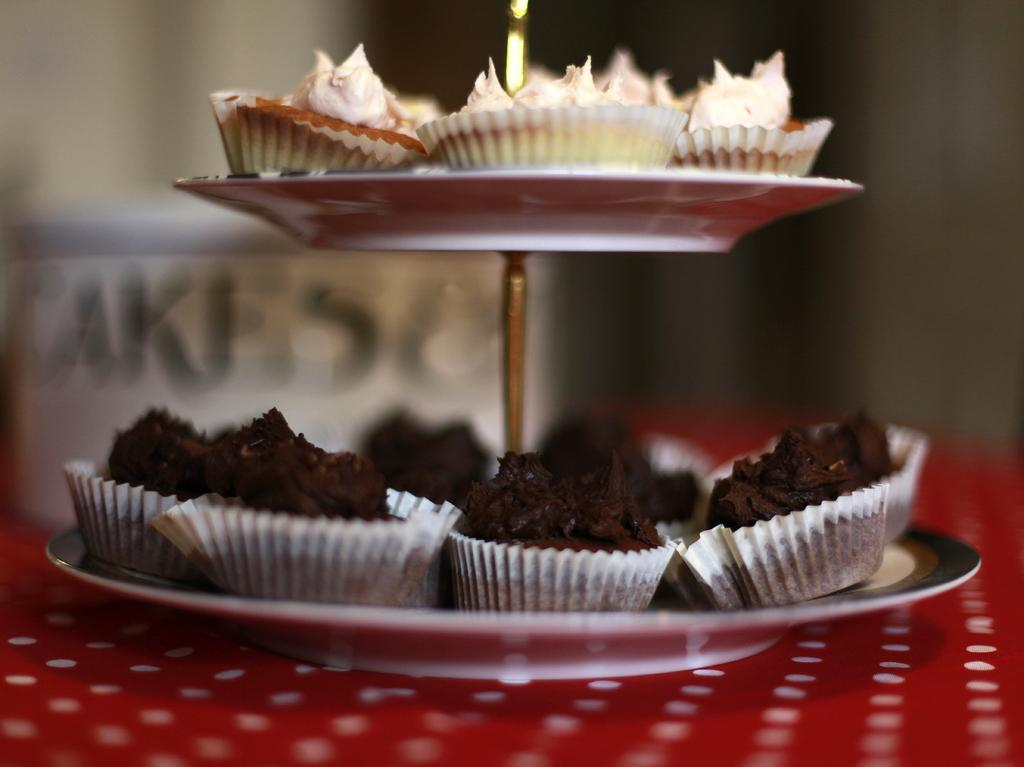What objects are located in the center of the image? There are plates in the center of the image. What is on the plates? The plates contain pies. Can you describe the background of the image? The background area of the image is blurred. What type of mitten can be seen on the pie in the image? There is no mitten present on the pie in the image. What type of loaf is being served alongside the pies in the image? There is no loaf present in the image; only pies are visible on the plates. 